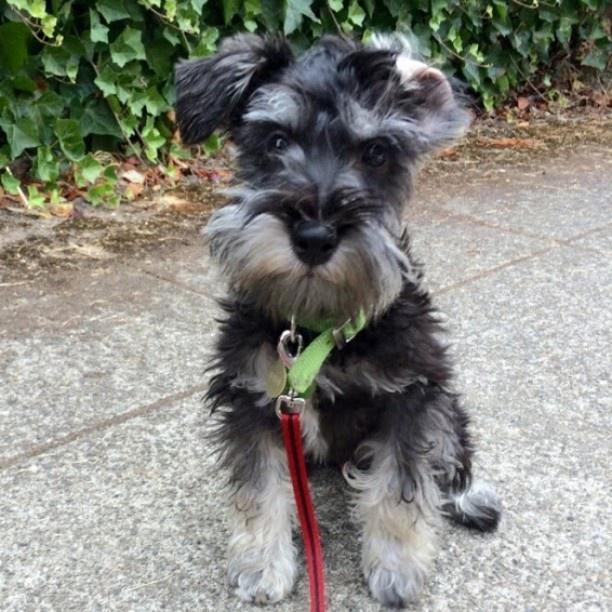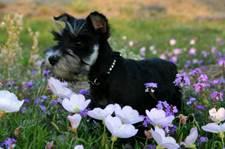The first image is the image on the left, the second image is the image on the right. For the images displayed, is the sentence "An image shows one schnauzer in the grass, with planted blooming flowers behind the dog but not in front of it." factually correct? Answer yes or no. No. The first image is the image on the left, the second image is the image on the right. Given the left and right images, does the statement "A person is standing with a group of dogs in the image on the left." hold true? Answer yes or no. No. 